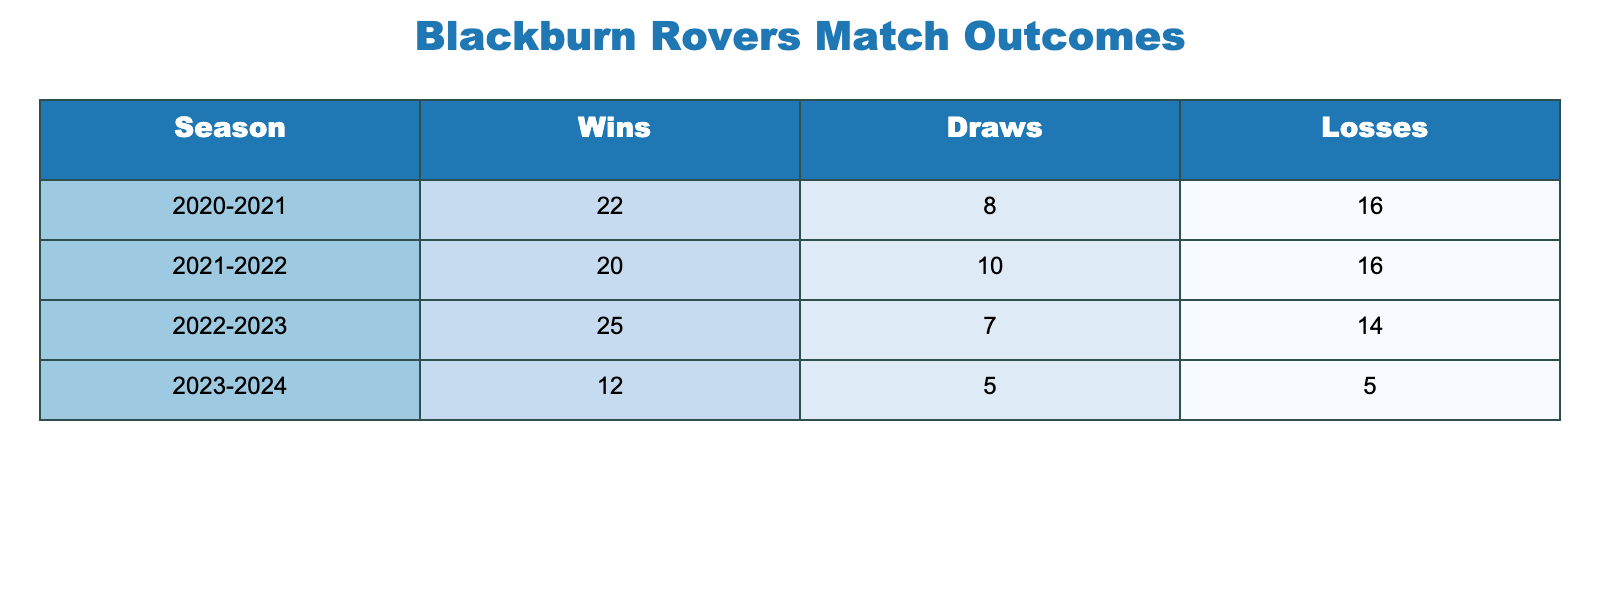What was Blackburn Rovers' total number of wins in the 2022-2023 season? According to the table, Blackburn Rovers had 25 wins in the 2022-2023 season. We can find this directly in the "Wins" column for the corresponding season.
Answer: 25 How many draws did Blackburn Rovers achieve in the most recent season? The most recent season listed is 2023-2024, where Blackburn Rovers recorded 5 draws. This value can be found directly in the "Draws" column for that season.
Answer: 5 Which season had the highest number of losses? The season with the highest number of losses is 2020-2021, with 16 losses. We can determine this by comparing the "Losses" column across all seasons displayed in the table.
Answer: 2020-2021 What is the average number of wins per season for Blackburn Rovers over these four seasons? To find the average wins, we sum the wins across all seasons: 22 + 20 + 25 + 12 = 79 wins. There are 4 seasons, so we divide 79 by 4, which equals 19.75.
Answer: 19.75 Did Blackburn Rovers have more wins than losses in the 2021-2022 season? In the 2021-2022 season, Blackburn Rovers had 20 wins and 16 losses. Since 20 is greater than 16, the answer is yes. This can be directly compared by examining the values in the respective columns for that season.
Answer: Yes What was the total number of games played by Blackburn Rovers in the 2020-2021 season? To find the total games played, we add the wins, draws, and losses: 22 wins + 8 draws + 16 losses = 46 games. This computation combines values from the corresponding row.
Answer: 46 In which season did Blackburn Rovers have the least number of total matches played? To find the season with the least total matches, we'll calculate the total for each season and find the minimum: 2020-2021 (46), 2021-2022 (46), 2022-2023 (46), 2023-2024 (22 + 5 + 5 = 32). The 2023-2024 season has the least with 32 matches.
Answer: 2023-2024 Was there a season where Blackburn Rovers had more draws than losses? In the 2021-2022 season, Blackburn had 10 draws and 16 losses. In the 2022-2023 season, they had 7 draws and 14 losses. However, in the 2020-2021 season, they had 8 draws and 16 losses. The 2023-2024 season had 5 draws and 5 losses, where draws were equal. Thus, the answer is no; there wasn’t a season where draws exceeded losses.
Answer: No What is the total number of draws across all seasons? By adding the number of draws in each season: 8 (2020-2021) + 10 (2021-2022) + 7 (2022-2023) + 5 (2023-2024) equals 30 draws in total. Thus, we calculate the sum of the "Draws" column.
Answer: 30 